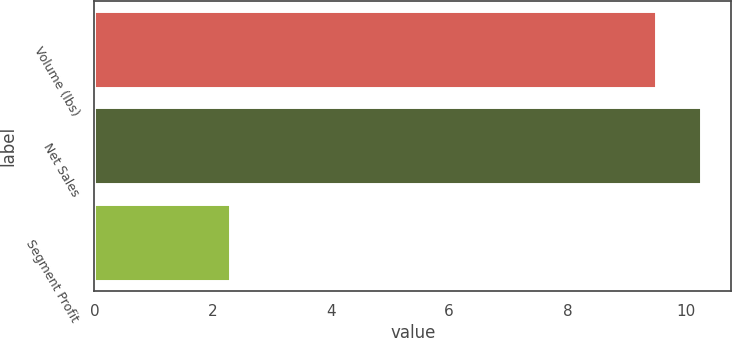<chart> <loc_0><loc_0><loc_500><loc_500><bar_chart><fcel>Volume (lbs)<fcel>Net Sales<fcel>Segment Profit<nl><fcel>9.5<fcel>10.26<fcel>2.3<nl></chart> 